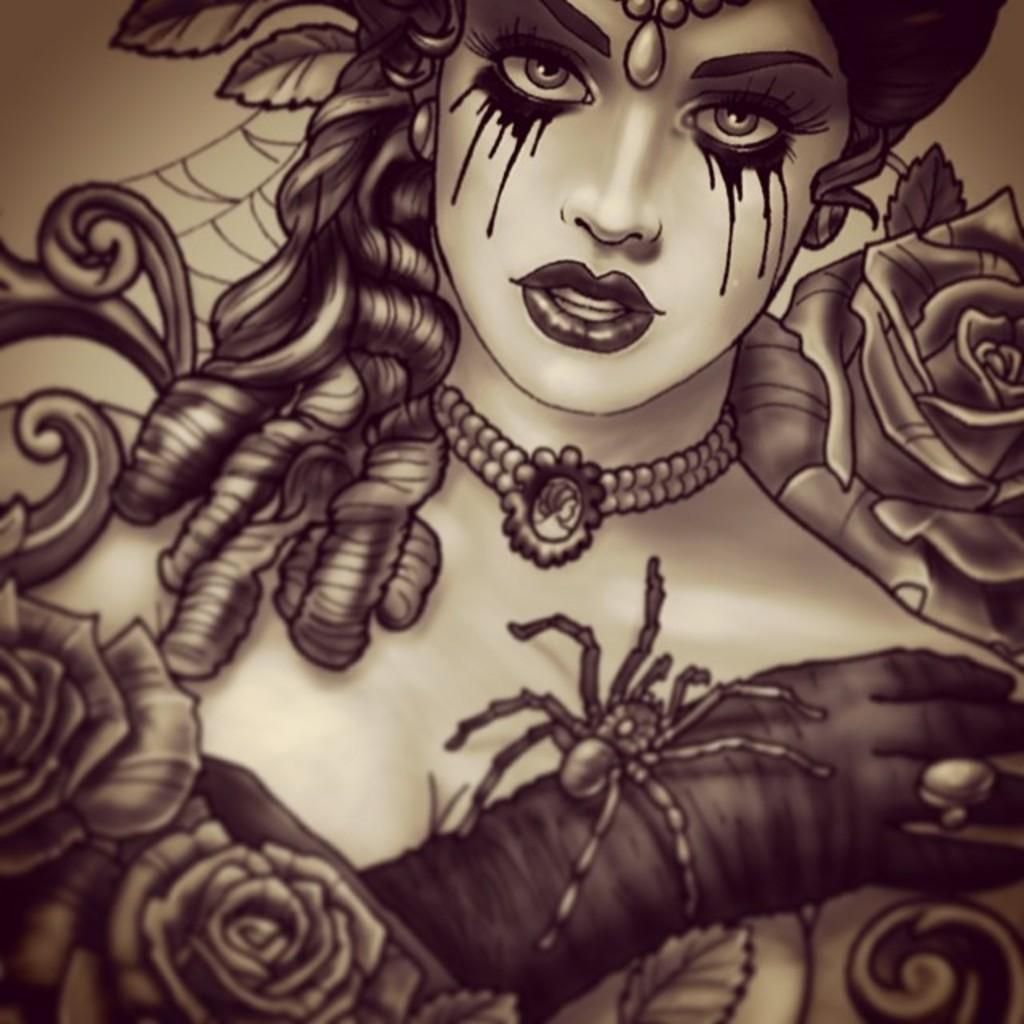What type of drawing is depicted in the image? The image is a sketch. Can you describe the main subject of the sketch? There is a lady in the sketch. What emotion is the lady expressing in the sketch? The lady is crying in the sketch. Are there any other elements in the sketch besides the lady? Yes, there is a spider on the lady's hand in the sketch. What type of glass is the lady holding in the sketch? There is no glass present in the sketch; the lady is not holding anything in her hands. 